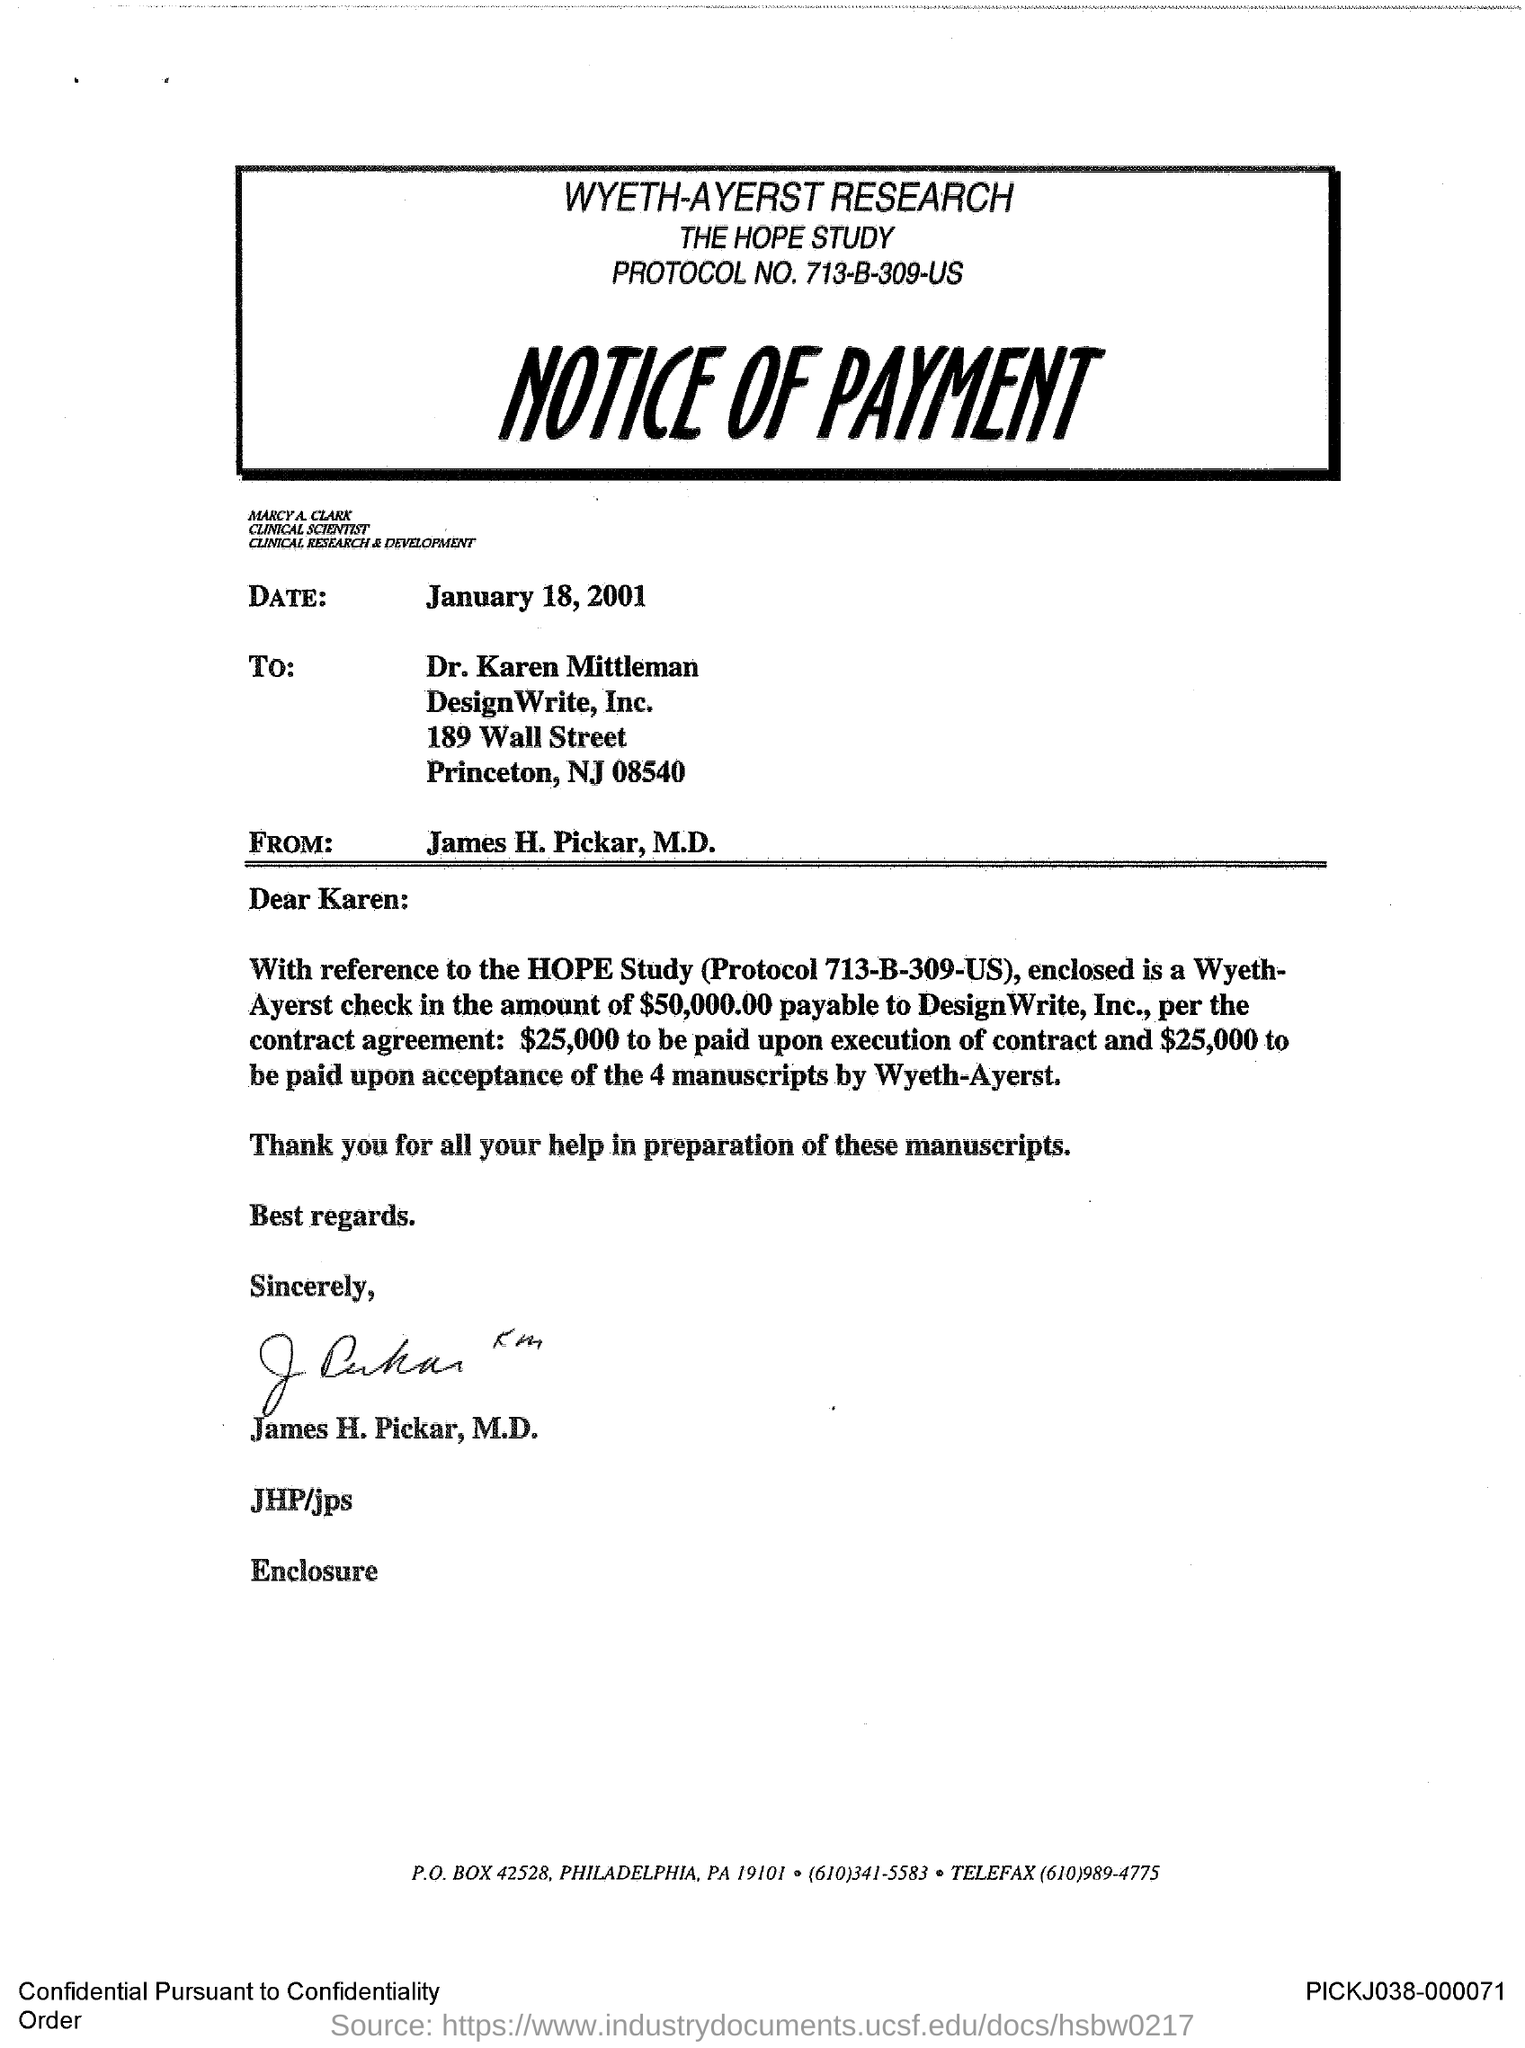What type of document is given here?
Your response must be concise. NOTICE OF PAYMENT. Who has signed the document?
Keep it short and to the point. James H. Pickar, M.D. To whom, the document is addressed?
Give a very brief answer. Dr. Karen Mittleman. What is the date mentioned in this document?
Give a very brief answer. January 18, 2001. 